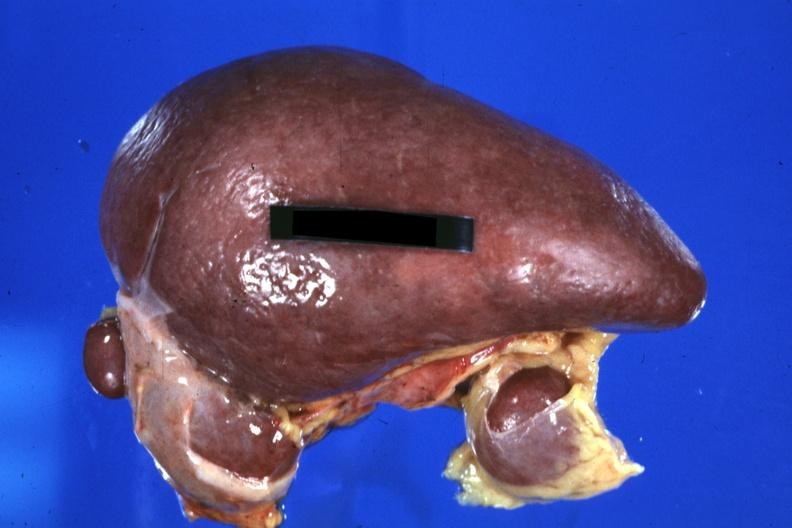what is present?
Answer the question using a single word or phrase. Polysplenia 